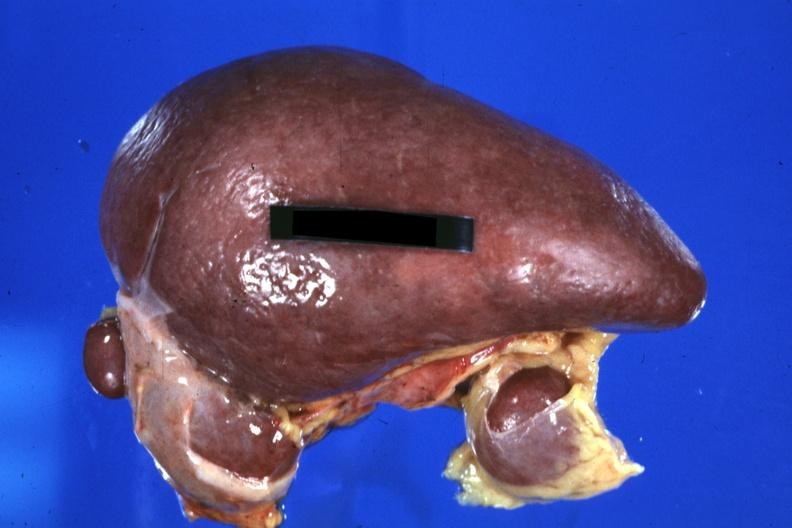what is present?
Answer the question using a single word or phrase. Polysplenia 